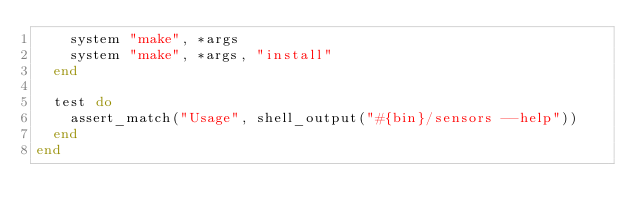Convert code to text. <code><loc_0><loc_0><loc_500><loc_500><_Ruby_>    system "make", *args
    system "make", *args, "install"
  end

  test do
    assert_match("Usage", shell_output("#{bin}/sensors --help"))
  end
end
</code> 